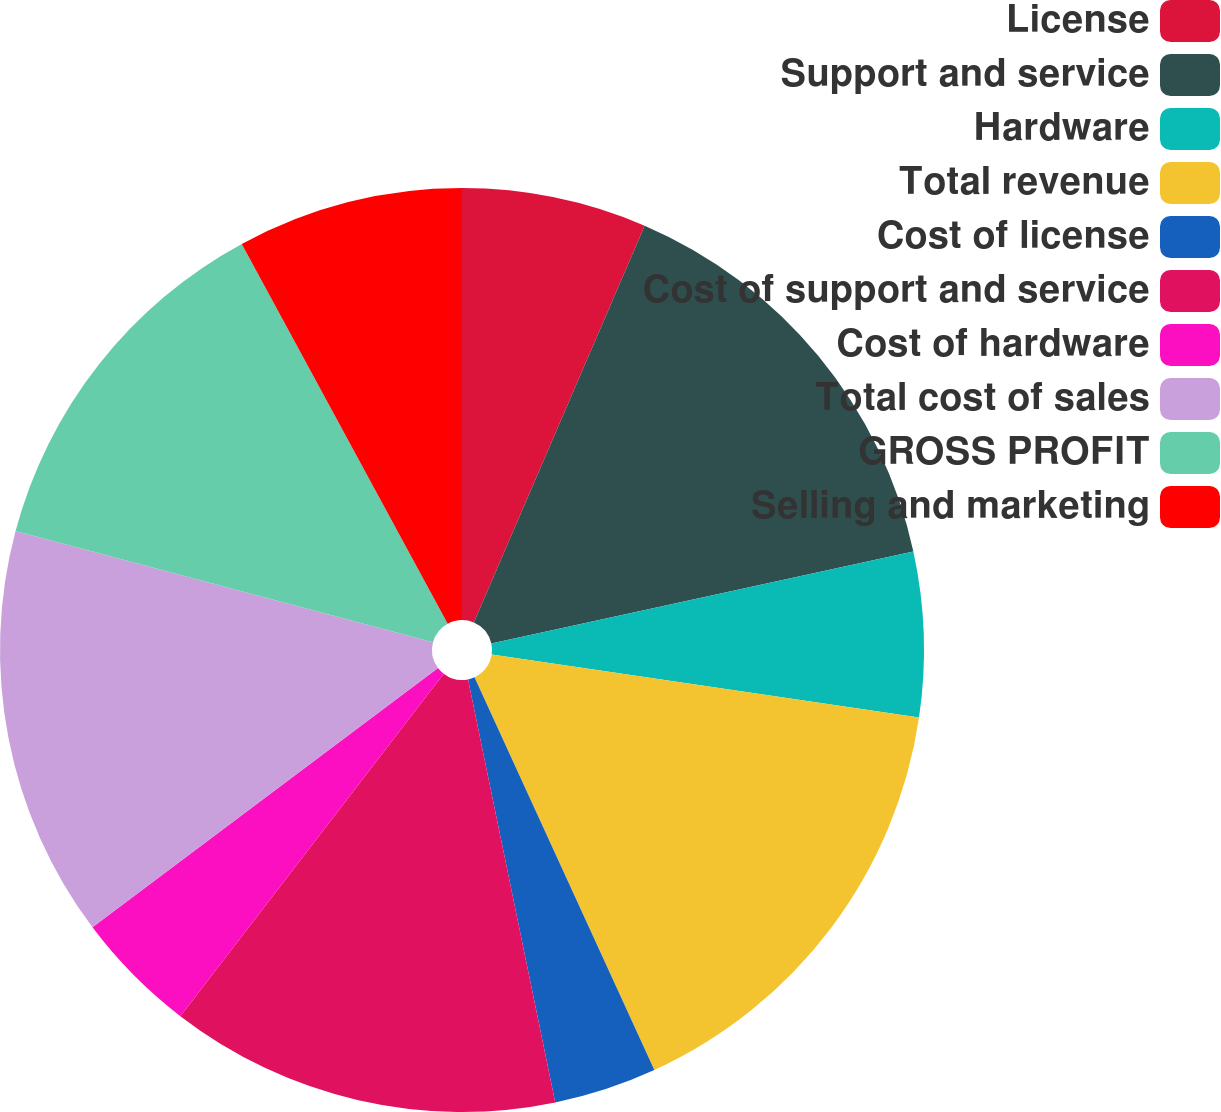Convert chart. <chart><loc_0><loc_0><loc_500><loc_500><pie_chart><fcel>License<fcel>Support and service<fcel>Hardware<fcel>Total revenue<fcel>Cost of license<fcel>Cost of support and service<fcel>Cost of hardware<fcel>Total cost of sales<fcel>GROSS PROFIT<fcel>Selling and marketing<nl><fcel>6.47%<fcel>15.11%<fcel>5.76%<fcel>15.83%<fcel>3.6%<fcel>13.67%<fcel>4.32%<fcel>14.39%<fcel>12.95%<fcel>7.91%<nl></chart> 